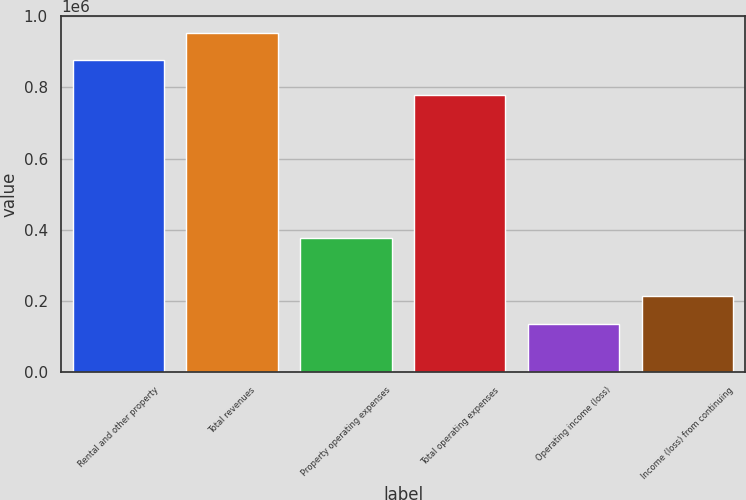Convert chart to OTSL. <chart><loc_0><loc_0><loc_500><loc_500><bar_chart><fcel>Rental and other property<fcel>Total revenues<fcel>Property operating expenses<fcel>Total operating expenses<fcel>Operating income (loss)<fcel>Income (loss) from continuing<nl><fcel>875694<fcel>953600<fcel>376164<fcel>779064<fcel>135291<fcel>213197<nl></chart> 